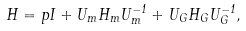<formula> <loc_0><loc_0><loc_500><loc_500>H = p I + U _ { m } H _ { m } U _ { m } ^ { - 1 } + U _ { G } H _ { G } U _ { G } ^ { - 1 } ,</formula> 